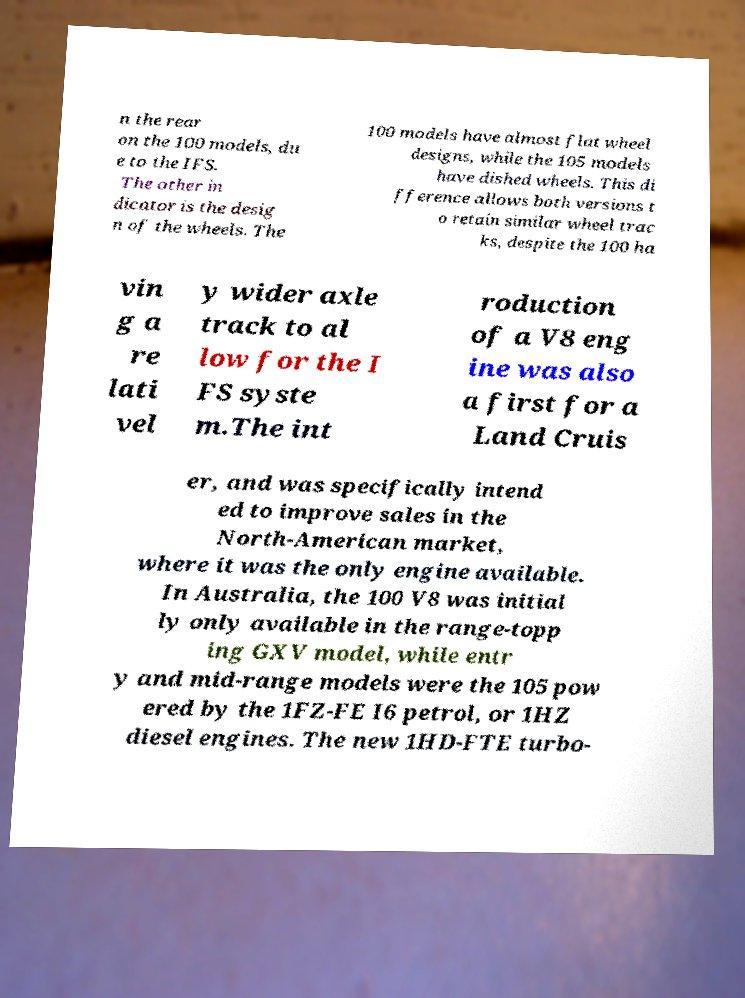Can you accurately transcribe the text from the provided image for me? n the rear on the 100 models, du e to the IFS. The other in dicator is the desig n of the wheels. The 100 models have almost flat wheel designs, while the 105 models have dished wheels. This di fference allows both versions t o retain similar wheel trac ks, despite the 100 ha vin g a re lati vel y wider axle track to al low for the I FS syste m.The int roduction of a V8 eng ine was also a first for a Land Cruis er, and was specifically intend ed to improve sales in the North-American market, where it was the only engine available. In Australia, the 100 V8 was initial ly only available in the range-topp ing GXV model, while entr y and mid-range models were the 105 pow ered by the 1FZ-FE I6 petrol, or 1HZ diesel engines. The new 1HD-FTE turbo- 